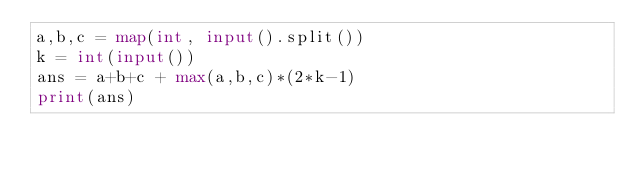Convert code to text. <code><loc_0><loc_0><loc_500><loc_500><_Python_>a,b,c = map(int, input().split())
k = int(input())
ans = a+b+c + max(a,b,c)*(2*k-1)
print(ans)
</code> 